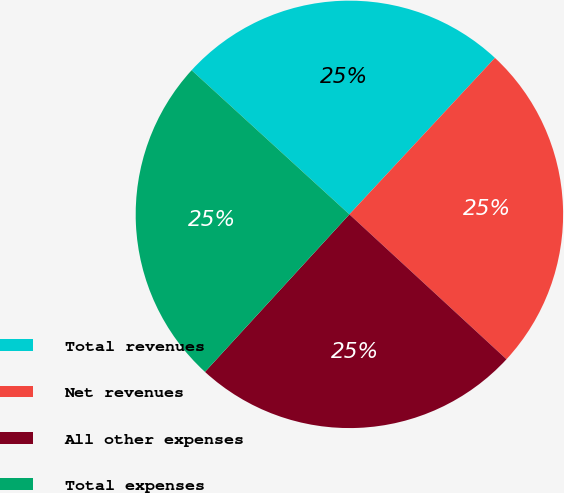<chart> <loc_0><loc_0><loc_500><loc_500><pie_chart><fcel>Total revenues<fcel>Net revenues<fcel>All other expenses<fcel>Total expenses<nl><fcel>25.14%<fcel>24.93%<fcel>24.95%<fcel>24.97%<nl></chart> 